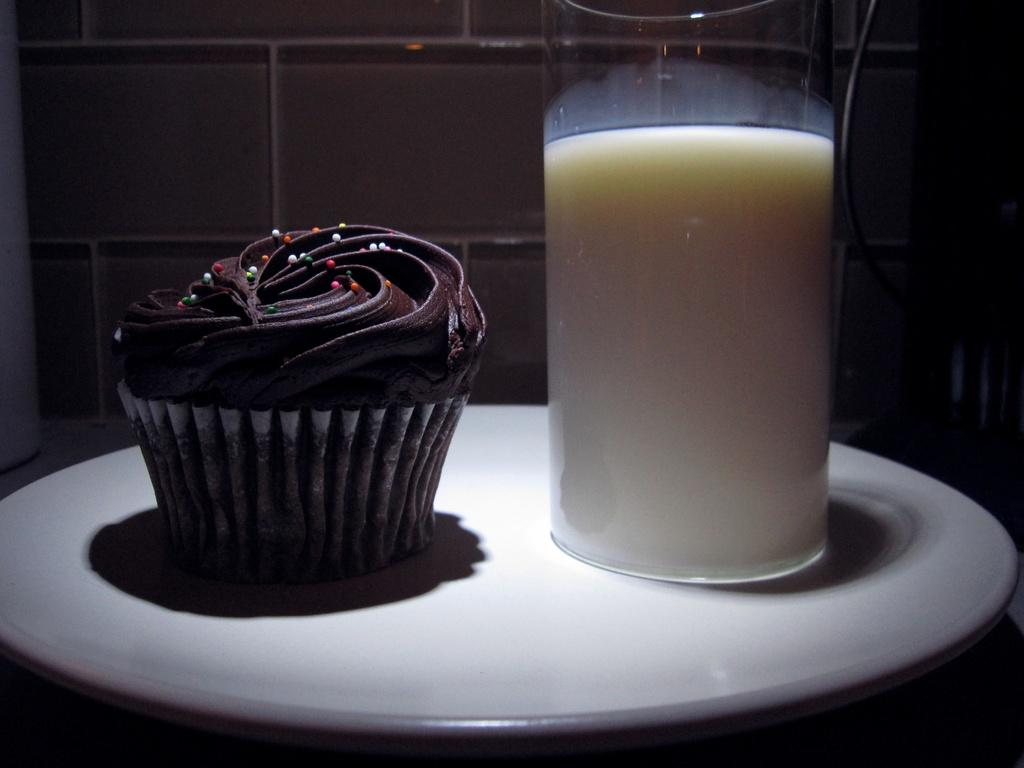What is in the glass that is visible in the image? There is a glass containing milk in the image. What type of dessert can be seen in the image? There is a cupcake placed on a plate in the image. What can be seen in the background of the image? There is a wall in the background of the image. What is the price of the leather juice in the image? There is no leather juice present in the image, and therefore no price can be determined. 